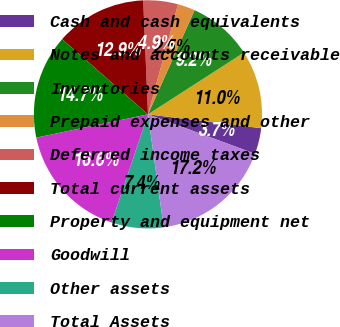<chart> <loc_0><loc_0><loc_500><loc_500><pie_chart><fcel>Cash and cash equivalents<fcel>Notes and accounts receivable<fcel>Inventories<fcel>Prepaid expenses and other<fcel>Deferred income taxes<fcel>Total current assets<fcel>Property and equipment net<fcel>Goodwill<fcel>Other assets<fcel>Total Assets<nl><fcel>3.68%<fcel>11.04%<fcel>9.2%<fcel>2.45%<fcel>4.91%<fcel>12.88%<fcel>14.72%<fcel>16.56%<fcel>7.36%<fcel>17.18%<nl></chart> 